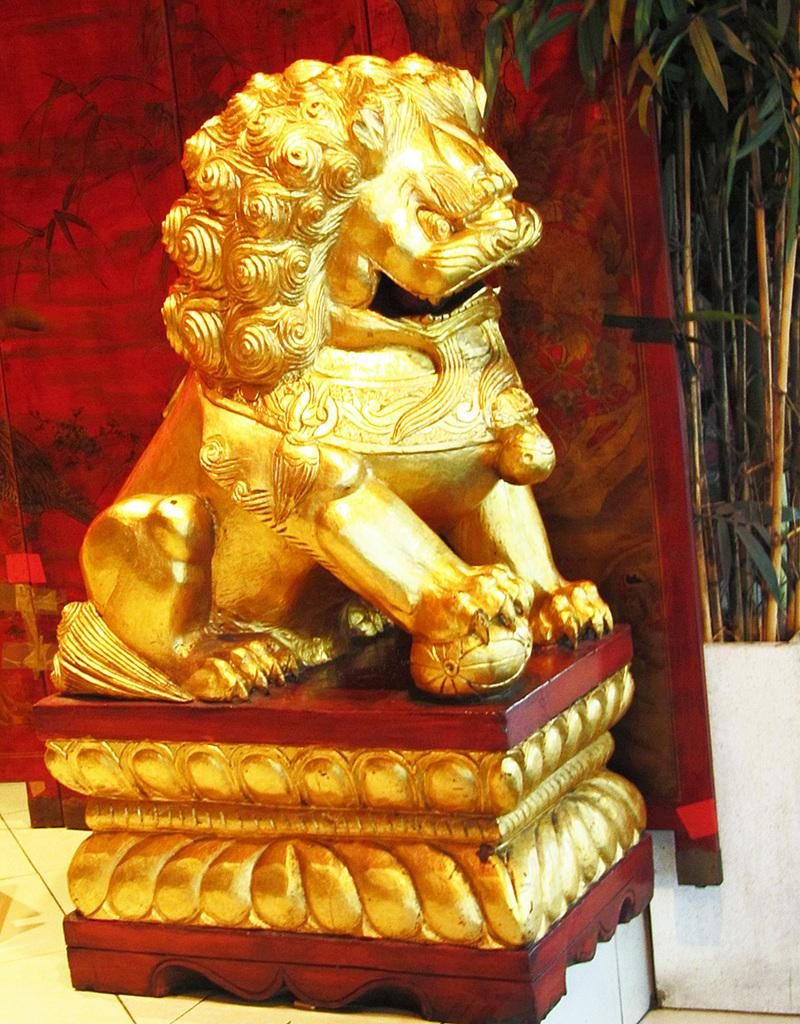What is the main subject in the middle of the image? There is a statue of a lion in the middle of the image. What can be seen in the background of the image? There is a painting and a flower pot in the background of the image. What type of vegetation is present in the background? There are plants in the background of the image. What type of letter is being written on the circle in the image? There is no letter or circle present in the image. What type of plough is being used to cultivate the plants in the image? There is no plough present in the image; the plants are not being cultivated. 